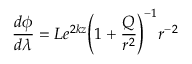<formula> <loc_0><loc_0><loc_500><loc_500>\frac { d \phi } { d \lambda } = L e ^ { 2 k z } { \left ( 1 + \frac { Q } { r ^ { 2 } } \right ) } ^ { - 1 } r ^ { - 2 }</formula> 